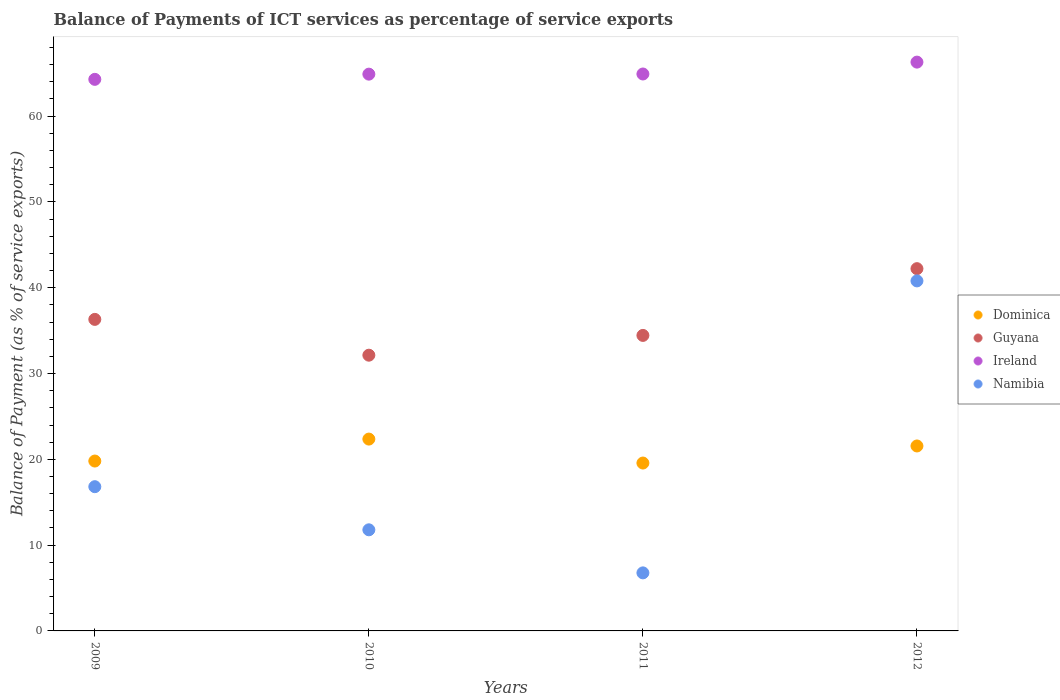What is the balance of payments of ICT services in Guyana in 2009?
Keep it short and to the point. 36.31. Across all years, what is the maximum balance of payments of ICT services in Guyana?
Your answer should be compact. 42.22. Across all years, what is the minimum balance of payments of ICT services in Guyana?
Offer a terse response. 32.14. In which year was the balance of payments of ICT services in Namibia maximum?
Your answer should be compact. 2012. In which year was the balance of payments of ICT services in Guyana minimum?
Provide a succinct answer. 2010. What is the total balance of payments of ICT services in Namibia in the graph?
Provide a short and direct response. 76.16. What is the difference between the balance of payments of ICT services in Dominica in 2010 and that in 2011?
Give a very brief answer. 2.79. What is the difference between the balance of payments of ICT services in Namibia in 2011 and the balance of payments of ICT services in Ireland in 2012?
Ensure brevity in your answer.  -59.53. What is the average balance of payments of ICT services in Dominica per year?
Give a very brief answer. 20.82. In the year 2009, what is the difference between the balance of payments of ICT services in Ireland and balance of payments of ICT services in Guyana?
Your answer should be compact. 27.98. In how many years, is the balance of payments of ICT services in Guyana greater than 28 %?
Give a very brief answer. 4. What is the ratio of the balance of payments of ICT services in Guyana in 2009 to that in 2011?
Provide a short and direct response. 1.05. Is the balance of payments of ICT services in Dominica in 2009 less than that in 2010?
Provide a succinct answer. Yes. What is the difference between the highest and the second highest balance of payments of ICT services in Guyana?
Make the answer very short. 5.91. What is the difference between the highest and the lowest balance of payments of ICT services in Ireland?
Keep it short and to the point. 2.01. In how many years, is the balance of payments of ICT services in Ireland greater than the average balance of payments of ICT services in Ireland taken over all years?
Offer a terse response. 1. Is the sum of the balance of payments of ICT services in Dominica in 2009 and 2010 greater than the maximum balance of payments of ICT services in Namibia across all years?
Provide a short and direct response. Yes. Is it the case that in every year, the sum of the balance of payments of ICT services in Ireland and balance of payments of ICT services in Guyana  is greater than the balance of payments of ICT services in Dominica?
Your response must be concise. Yes. Does the balance of payments of ICT services in Ireland monotonically increase over the years?
Make the answer very short. Yes. How many dotlines are there?
Provide a succinct answer. 4. Does the graph contain any zero values?
Offer a very short reply. No. Where does the legend appear in the graph?
Keep it short and to the point. Center right. How many legend labels are there?
Your response must be concise. 4. How are the legend labels stacked?
Offer a terse response. Vertical. What is the title of the graph?
Your answer should be compact. Balance of Payments of ICT services as percentage of service exports. What is the label or title of the Y-axis?
Provide a short and direct response. Balance of Payment (as % of service exports). What is the Balance of Payment (as % of service exports) in Dominica in 2009?
Make the answer very short. 19.8. What is the Balance of Payment (as % of service exports) in Guyana in 2009?
Your answer should be compact. 36.31. What is the Balance of Payment (as % of service exports) of Ireland in 2009?
Make the answer very short. 64.29. What is the Balance of Payment (as % of service exports) of Namibia in 2009?
Give a very brief answer. 16.81. What is the Balance of Payment (as % of service exports) of Dominica in 2010?
Keep it short and to the point. 22.36. What is the Balance of Payment (as % of service exports) in Guyana in 2010?
Your response must be concise. 32.14. What is the Balance of Payment (as % of service exports) of Ireland in 2010?
Your answer should be compact. 64.89. What is the Balance of Payment (as % of service exports) of Namibia in 2010?
Make the answer very short. 11.78. What is the Balance of Payment (as % of service exports) of Dominica in 2011?
Provide a short and direct response. 19.57. What is the Balance of Payment (as % of service exports) in Guyana in 2011?
Offer a very short reply. 34.44. What is the Balance of Payment (as % of service exports) in Ireland in 2011?
Provide a succinct answer. 64.91. What is the Balance of Payment (as % of service exports) of Namibia in 2011?
Provide a short and direct response. 6.77. What is the Balance of Payment (as % of service exports) in Dominica in 2012?
Offer a terse response. 21.56. What is the Balance of Payment (as % of service exports) of Guyana in 2012?
Make the answer very short. 42.22. What is the Balance of Payment (as % of service exports) of Ireland in 2012?
Your answer should be very brief. 66.3. What is the Balance of Payment (as % of service exports) of Namibia in 2012?
Your answer should be very brief. 40.79. Across all years, what is the maximum Balance of Payment (as % of service exports) in Dominica?
Ensure brevity in your answer.  22.36. Across all years, what is the maximum Balance of Payment (as % of service exports) in Guyana?
Provide a short and direct response. 42.22. Across all years, what is the maximum Balance of Payment (as % of service exports) in Ireland?
Keep it short and to the point. 66.3. Across all years, what is the maximum Balance of Payment (as % of service exports) of Namibia?
Ensure brevity in your answer.  40.79. Across all years, what is the minimum Balance of Payment (as % of service exports) in Dominica?
Provide a succinct answer. 19.57. Across all years, what is the minimum Balance of Payment (as % of service exports) in Guyana?
Your answer should be very brief. 32.14. Across all years, what is the minimum Balance of Payment (as % of service exports) of Ireland?
Ensure brevity in your answer.  64.29. Across all years, what is the minimum Balance of Payment (as % of service exports) of Namibia?
Give a very brief answer. 6.77. What is the total Balance of Payment (as % of service exports) in Dominica in the graph?
Your answer should be very brief. 83.28. What is the total Balance of Payment (as % of service exports) in Guyana in the graph?
Keep it short and to the point. 145.11. What is the total Balance of Payment (as % of service exports) in Ireland in the graph?
Ensure brevity in your answer.  260.38. What is the total Balance of Payment (as % of service exports) of Namibia in the graph?
Offer a very short reply. 76.16. What is the difference between the Balance of Payment (as % of service exports) in Dominica in 2009 and that in 2010?
Your answer should be very brief. -2.56. What is the difference between the Balance of Payment (as % of service exports) in Guyana in 2009 and that in 2010?
Your response must be concise. 4.17. What is the difference between the Balance of Payment (as % of service exports) in Ireland in 2009 and that in 2010?
Make the answer very short. -0.61. What is the difference between the Balance of Payment (as % of service exports) of Namibia in 2009 and that in 2010?
Your answer should be very brief. 5.03. What is the difference between the Balance of Payment (as % of service exports) in Dominica in 2009 and that in 2011?
Offer a terse response. 0.23. What is the difference between the Balance of Payment (as % of service exports) in Guyana in 2009 and that in 2011?
Give a very brief answer. 1.87. What is the difference between the Balance of Payment (as % of service exports) in Ireland in 2009 and that in 2011?
Ensure brevity in your answer.  -0.62. What is the difference between the Balance of Payment (as % of service exports) in Namibia in 2009 and that in 2011?
Your response must be concise. 10.05. What is the difference between the Balance of Payment (as % of service exports) in Dominica in 2009 and that in 2012?
Your answer should be very brief. -1.76. What is the difference between the Balance of Payment (as % of service exports) in Guyana in 2009 and that in 2012?
Ensure brevity in your answer.  -5.91. What is the difference between the Balance of Payment (as % of service exports) in Ireland in 2009 and that in 2012?
Offer a terse response. -2.01. What is the difference between the Balance of Payment (as % of service exports) in Namibia in 2009 and that in 2012?
Offer a terse response. -23.98. What is the difference between the Balance of Payment (as % of service exports) in Dominica in 2010 and that in 2011?
Your answer should be compact. 2.79. What is the difference between the Balance of Payment (as % of service exports) of Guyana in 2010 and that in 2011?
Your response must be concise. -2.3. What is the difference between the Balance of Payment (as % of service exports) in Ireland in 2010 and that in 2011?
Provide a short and direct response. -0.02. What is the difference between the Balance of Payment (as % of service exports) in Namibia in 2010 and that in 2011?
Provide a succinct answer. 5.02. What is the difference between the Balance of Payment (as % of service exports) in Dominica in 2010 and that in 2012?
Your answer should be compact. 0.8. What is the difference between the Balance of Payment (as % of service exports) of Guyana in 2010 and that in 2012?
Your answer should be very brief. -10.08. What is the difference between the Balance of Payment (as % of service exports) in Ireland in 2010 and that in 2012?
Provide a succinct answer. -1.4. What is the difference between the Balance of Payment (as % of service exports) of Namibia in 2010 and that in 2012?
Your response must be concise. -29.01. What is the difference between the Balance of Payment (as % of service exports) in Dominica in 2011 and that in 2012?
Your answer should be compact. -1.99. What is the difference between the Balance of Payment (as % of service exports) in Guyana in 2011 and that in 2012?
Your response must be concise. -7.78. What is the difference between the Balance of Payment (as % of service exports) in Ireland in 2011 and that in 2012?
Your answer should be compact. -1.38. What is the difference between the Balance of Payment (as % of service exports) of Namibia in 2011 and that in 2012?
Give a very brief answer. -34.03. What is the difference between the Balance of Payment (as % of service exports) in Dominica in 2009 and the Balance of Payment (as % of service exports) in Guyana in 2010?
Your answer should be very brief. -12.34. What is the difference between the Balance of Payment (as % of service exports) of Dominica in 2009 and the Balance of Payment (as % of service exports) of Ireland in 2010?
Give a very brief answer. -45.09. What is the difference between the Balance of Payment (as % of service exports) of Dominica in 2009 and the Balance of Payment (as % of service exports) of Namibia in 2010?
Make the answer very short. 8.02. What is the difference between the Balance of Payment (as % of service exports) in Guyana in 2009 and the Balance of Payment (as % of service exports) in Ireland in 2010?
Keep it short and to the point. -28.58. What is the difference between the Balance of Payment (as % of service exports) in Guyana in 2009 and the Balance of Payment (as % of service exports) in Namibia in 2010?
Provide a succinct answer. 24.52. What is the difference between the Balance of Payment (as % of service exports) of Ireland in 2009 and the Balance of Payment (as % of service exports) of Namibia in 2010?
Offer a very short reply. 52.5. What is the difference between the Balance of Payment (as % of service exports) in Dominica in 2009 and the Balance of Payment (as % of service exports) in Guyana in 2011?
Offer a very short reply. -14.64. What is the difference between the Balance of Payment (as % of service exports) in Dominica in 2009 and the Balance of Payment (as % of service exports) in Ireland in 2011?
Your answer should be very brief. -45.11. What is the difference between the Balance of Payment (as % of service exports) of Dominica in 2009 and the Balance of Payment (as % of service exports) of Namibia in 2011?
Make the answer very short. 13.03. What is the difference between the Balance of Payment (as % of service exports) in Guyana in 2009 and the Balance of Payment (as % of service exports) in Ireland in 2011?
Your answer should be very brief. -28.6. What is the difference between the Balance of Payment (as % of service exports) in Guyana in 2009 and the Balance of Payment (as % of service exports) in Namibia in 2011?
Offer a terse response. 29.54. What is the difference between the Balance of Payment (as % of service exports) of Ireland in 2009 and the Balance of Payment (as % of service exports) of Namibia in 2011?
Your answer should be very brief. 57.52. What is the difference between the Balance of Payment (as % of service exports) in Dominica in 2009 and the Balance of Payment (as % of service exports) in Guyana in 2012?
Make the answer very short. -22.42. What is the difference between the Balance of Payment (as % of service exports) in Dominica in 2009 and the Balance of Payment (as % of service exports) in Ireland in 2012?
Make the answer very short. -46.5. What is the difference between the Balance of Payment (as % of service exports) in Dominica in 2009 and the Balance of Payment (as % of service exports) in Namibia in 2012?
Ensure brevity in your answer.  -20.99. What is the difference between the Balance of Payment (as % of service exports) in Guyana in 2009 and the Balance of Payment (as % of service exports) in Ireland in 2012?
Give a very brief answer. -29.99. What is the difference between the Balance of Payment (as % of service exports) in Guyana in 2009 and the Balance of Payment (as % of service exports) in Namibia in 2012?
Give a very brief answer. -4.49. What is the difference between the Balance of Payment (as % of service exports) of Ireland in 2009 and the Balance of Payment (as % of service exports) of Namibia in 2012?
Your response must be concise. 23.49. What is the difference between the Balance of Payment (as % of service exports) in Dominica in 2010 and the Balance of Payment (as % of service exports) in Guyana in 2011?
Your answer should be very brief. -12.08. What is the difference between the Balance of Payment (as % of service exports) in Dominica in 2010 and the Balance of Payment (as % of service exports) in Ireland in 2011?
Your response must be concise. -42.55. What is the difference between the Balance of Payment (as % of service exports) in Dominica in 2010 and the Balance of Payment (as % of service exports) in Namibia in 2011?
Your response must be concise. 15.59. What is the difference between the Balance of Payment (as % of service exports) of Guyana in 2010 and the Balance of Payment (as % of service exports) of Ireland in 2011?
Ensure brevity in your answer.  -32.77. What is the difference between the Balance of Payment (as % of service exports) of Guyana in 2010 and the Balance of Payment (as % of service exports) of Namibia in 2011?
Give a very brief answer. 25.37. What is the difference between the Balance of Payment (as % of service exports) in Ireland in 2010 and the Balance of Payment (as % of service exports) in Namibia in 2011?
Your response must be concise. 58.13. What is the difference between the Balance of Payment (as % of service exports) in Dominica in 2010 and the Balance of Payment (as % of service exports) in Guyana in 2012?
Your answer should be very brief. -19.86. What is the difference between the Balance of Payment (as % of service exports) in Dominica in 2010 and the Balance of Payment (as % of service exports) in Ireland in 2012?
Keep it short and to the point. -43.94. What is the difference between the Balance of Payment (as % of service exports) in Dominica in 2010 and the Balance of Payment (as % of service exports) in Namibia in 2012?
Keep it short and to the point. -18.44. What is the difference between the Balance of Payment (as % of service exports) in Guyana in 2010 and the Balance of Payment (as % of service exports) in Ireland in 2012?
Give a very brief answer. -34.16. What is the difference between the Balance of Payment (as % of service exports) in Guyana in 2010 and the Balance of Payment (as % of service exports) in Namibia in 2012?
Your answer should be compact. -8.66. What is the difference between the Balance of Payment (as % of service exports) of Ireland in 2010 and the Balance of Payment (as % of service exports) of Namibia in 2012?
Provide a short and direct response. 24.1. What is the difference between the Balance of Payment (as % of service exports) of Dominica in 2011 and the Balance of Payment (as % of service exports) of Guyana in 2012?
Keep it short and to the point. -22.65. What is the difference between the Balance of Payment (as % of service exports) in Dominica in 2011 and the Balance of Payment (as % of service exports) in Ireland in 2012?
Keep it short and to the point. -46.73. What is the difference between the Balance of Payment (as % of service exports) of Dominica in 2011 and the Balance of Payment (as % of service exports) of Namibia in 2012?
Ensure brevity in your answer.  -21.23. What is the difference between the Balance of Payment (as % of service exports) of Guyana in 2011 and the Balance of Payment (as % of service exports) of Ireland in 2012?
Keep it short and to the point. -31.85. What is the difference between the Balance of Payment (as % of service exports) of Guyana in 2011 and the Balance of Payment (as % of service exports) of Namibia in 2012?
Provide a short and direct response. -6.35. What is the difference between the Balance of Payment (as % of service exports) in Ireland in 2011 and the Balance of Payment (as % of service exports) in Namibia in 2012?
Your response must be concise. 24.12. What is the average Balance of Payment (as % of service exports) of Dominica per year?
Your response must be concise. 20.82. What is the average Balance of Payment (as % of service exports) in Guyana per year?
Offer a very short reply. 36.28. What is the average Balance of Payment (as % of service exports) of Ireland per year?
Your answer should be very brief. 65.1. What is the average Balance of Payment (as % of service exports) in Namibia per year?
Provide a succinct answer. 19.04. In the year 2009, what is the difference between the Balance of Payment (as % of service exports) of Dominica and Balance of Payment (as % of service exports) of Guyana?
Your answer should be very brief. -16.51. In the year 2009, what is the difference between the Balance of Payment (as % of service exports) in Dominica and Balance of Payment (as % of service exports) in Ireland?
Make the answer very short. -44.49. In the year 2009, what is the difference between the Balance of Payment (as % of service exports) in Dominica and Balance of Payment (as % of service exports) in Namibia?
Ensure brevity in your answer.  2.99. In the year 2009, what is the difference between the Balance of Payment (as % of service exports) of Guyana and Balance of Payment (as % of service exports) of Ireland?
Offer a very short reply. -27.98. In the year 2009, what is the difference between the Balance of Payment (as % of service exports) in Guyana and Balance of Payment (as % of service exports) in Namibia?
Keep it short and to the point. 19.5. In the year 2009, what is the difference between the Balance of Payment (as % of service exports) in Ireland and Balance of Payment (as % of service exports) in Namibia?
Your answer should be compact. 47.48. In the year 2010, what is the difference between the Balance of Payment (as % of service exports) of Dominica and Balance of Payment (as % of service exports) of Guyana?
Your answer should be very brief. -9.78. In the year 2010, what is the difference between the Balance of Payment (as % of service exports) in Dominica and Balance of Payment (as % of service exports) in Ireland?
Keep it short and to the point. -42.53. In the year 2010, what is the difference between the Balance of Payment (as % of service exports) of Dominica and Balance of Payment (as % of service exports) of Namibia?
Your answer should be compact. 10.57. In the year 2010, what is the difference between the Balance of Payment (as % of service exports) of Guyana and Balance of Payment (as % of service exports) of Ireland?
Keep it short and to the point. -32.76. In the year 2010, what is the difference between the Balance of Payment (as % of service exports) in Guyana and Balance of Payment (as % of service exports) in Namibia?
Make the answer very short. 20.35. In the year 2010, what is the difference between the Balance of Payment (as % of service exports) of Ireland and Balance of Payment (as % of service exports) of Namibia?
Your answer should be very brief. 53.11. In the year 2011, what is the difference between the Balance of Payment (as % of service exports) in Dominica and Balance of Payment (as % of service exports) in Guyana?
Your response must be concise. -14.87. In the year 2011, what is the difference between the Balance of Payment (as % of service exports) of Dominica and Balance of Payment (as % of service exports) of Ireland?
Offer a very short reply. -45.34. In the year 2011, what is the difference between the Balance of Payment (as % of service exports) of Dominica and Balance of Payment (as % of service exports) of Namibia?
Your response must be concise. 12.8. In the year 2011, what is the difference between the Balance of Payment (as % of service exports) of Guyana and Balance of Payment (as % of service exports) of Ireland?
Provide a succinct answer. -30.47. In the year 2011, what is the difference between the Balance of Payment (as % of service exports) of Guyana and Balance of Payment (as % of service exports) of Namibia?
Provide a short and direct response. 27.68. In the year 2011, what is the difference between the Balance of Payment (as % of service exports) in Ireland and Balance of Payment (as % of service exports) in Namibia?
Provide a succinct answer. 58.15. In the year 2012, what is the difference between the Balance of Payment (as % of service exports) in Dominica and Balance of Payment (as % of service exports) in Guyana?
Give a very brief answer. -20.66. In the year 2012, what is the difference between the Balance of Payment (as % of service exports) in Dominica and Balance of Payment (as % of service exports) in Ireland?
Provide a short and direct response. -44.74. In the year 2012, what is the difference between the Balance of Payment (as % of service exports) in Dominica and Balance of Payment (as % of service exports) in Namibia?
Your answer should be compact. -19.24. In the year 2012, what is the difference between the Balance of Payment (as % of service exports) in Guyana and Balance of Payment (as % of service exports) in Ireland?
Your response must be concise. -24.07. In the year 2012, what is the difference between the Balance of Payment (as % of service exports) of Guyana and Balance of Payment (as % of service exports) of Namibia?
Keep it short and to the point. 1.43. In the year 2012, what is the difference between the Balance of Payment (as % of service exports) in Ireland and Balance of Payment (as % of service exports) in Namibia?
Your response must be concise. 25.5. What is the ratio of the Balance of Payment (as % of service exports) of Dominica in 2009 to that in 2010?
Offer a very short reply. 0.89. What is the ratio of the Balance of Payment (as % of service exports) of Guyana in 2009 to that in 2010?
Offer a terse response. 1.13. What is the ratio of the Balance of Payment (as % of service exports) of Ireland in 2009 to that in 2010?
Provide a succinct answer. 0.99. What is the ratio of the Balance of Payment (as % of service exports) of Namibia in 2009 to that in 2010?
Offer a terse response. 1.43. What is the ratio of the Balance of Payment (as % of service exports) of Dominica in 2009 to that in 2011?
Provide a short and direct response. 1.01. What is the ratio of the Balance of Payment (as % of service exports) in Guyana in 2009 to that in 2011?
Your answer should be very brief. 1.05. What is the ratio of the Balance of Payment (as % of service exports) in Namibia in 2009 to that in 2011?
Offer a very short reply. 2.48. What is the ratio of the Balance of Payment (as % of service exports) of Dominica in 2009 to that in 2012?
Give a very brief answer. 0.92. What is the ratio of the Balance of Payment (as % of service exports) in Guyana in 2009 to that in 2012?
Provide a succinct answer. 0.86. What is the ratio of the Balance of Payment (as % of service exports) of Ireland in 2009 to that in 2012?
Make the answer very short. 0.97. What is the ratio of the Balance of Payment (as % of service exports) in Namibia in 2009 to that in 2012?
Make the answer very short. 0.41. What is the ratio of the Balance of Payment (as % of service exports) in Dominica in 2010 to that in 2011?
Your answer should be compact. 1.14. What is the ratio of the Balance of Payment (as % of service exports) in Guyana in 2010 to that in 2011?
Provide a succinct answer. 0.93. What is the ratio of the Balance of Payment (as % of service exports) of Namibia in 2010 to that in 2011?
Ensure brevity in your answer.  1.74. What is the ratio of the Balance of Payment (as % of service exports) in Dominica in 2010 to that in 2012?
Offer a very short reply. 1.04. What is the ratio of the Balance of Payment (as % of service exports) in Guyana in 2010 to that in 2012?
Your answer should be compact. 0.76. What is the ratio of the Balance of Payment (as % of service exports) of Ireland in 2010 to that in 2012?
Offer a very short reply. 0.98. What is the ratio of the Balance of Payment (as % of service exports) of Namibia in 2010 to that in 2012?
Provide a short and direct response. 0.29. What is the ratio of the Balance of Payment (as % of service exports) in Dominica in 2011 to that in 2012?
Give a very brief answer. 0.91. What is the ratio of the Balance of Payment (as % of service exports) in Guyana in 2011 to that in 2012?
Offer a very short reply. 0.82. What is the ratio of the Balance of Payment (as % of service exports) in Ireland in 2011 to that in 2012?
Offer a terse response. 0.98. What is the ratio of the Balance of Payment (as % of service exports) in Namibia in 2011 to that in 2012?
Give a very brief answer. 0.17. What is the difference between the highest and the second highest Balance of Payment (as % of service exports) in Dominica?
Give a very brief answer. 0.8. What is the difference between the highest and the second highest Balance of Payment (as % of service exports) of Guyana?
Keep it short and to the point. 5.91. What is the difference between the highest and the second highest Balance of Payment (as % of service exports) in Ireland?
Your answer should be very brief. 1.38. What is the difference between the highest and the second highest Balance of Payment (as % of service exports) in Namibia?
Offer a very short reply. 23.98. What is the difference between the highest and the lowest Balance of Payment (as % of service exports) of Dominica?
Keep it short and to the point. 2.79. What is the difference between the highest and the lowest Balance of Payment (as % of service exports) of Guyana?
Offer a terse response. 10.08. What is the difference between the highest and the lowest Balance of Payment (as % of service exports) of Ireland?
Make the answer very short. 2.01. What is the difference between the highest and the lowest Balance of Payment (as % of service exports) in Namibia?
Offer a very short reply. 34.03. 